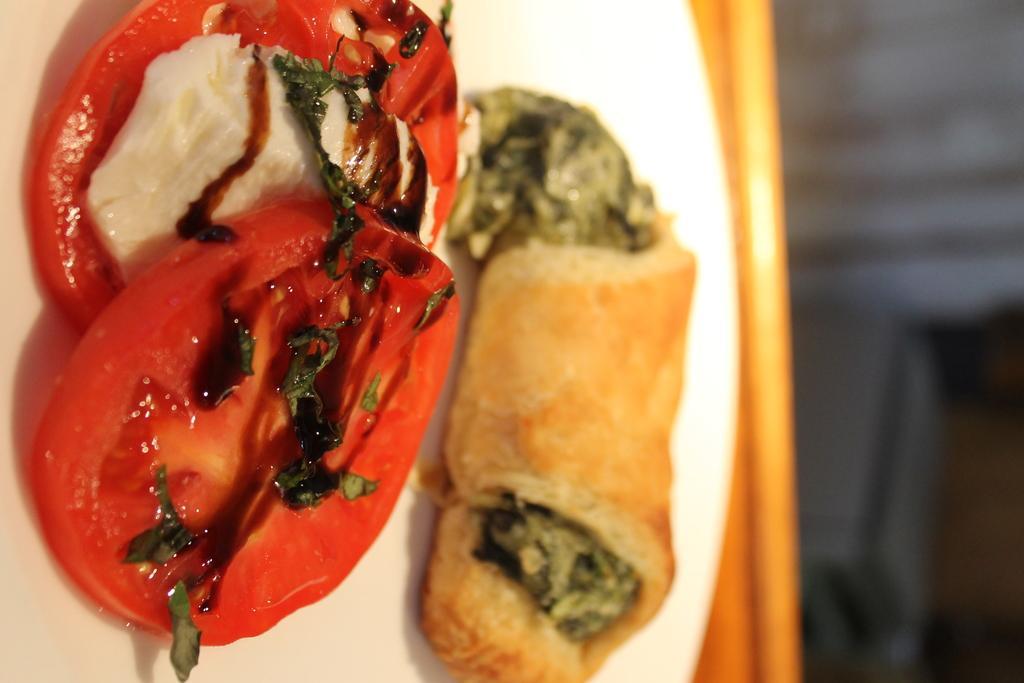Can you describe this image briefly? In this image I can see a white colour plate and in it I can see two slices of a tomato, leaves and few other foodstuffs. I can also see this image is little bit blurry. 